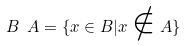Convert formula to latex. <formula><loc_0><loc_0><loc_500><loc_500>B \ A = \{ x \in B | x \notin A \}</formula> 